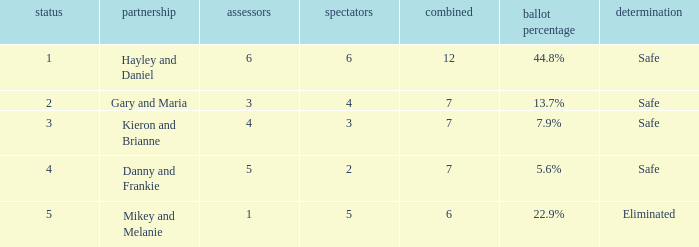What was the result for the total of 12? Safe. 